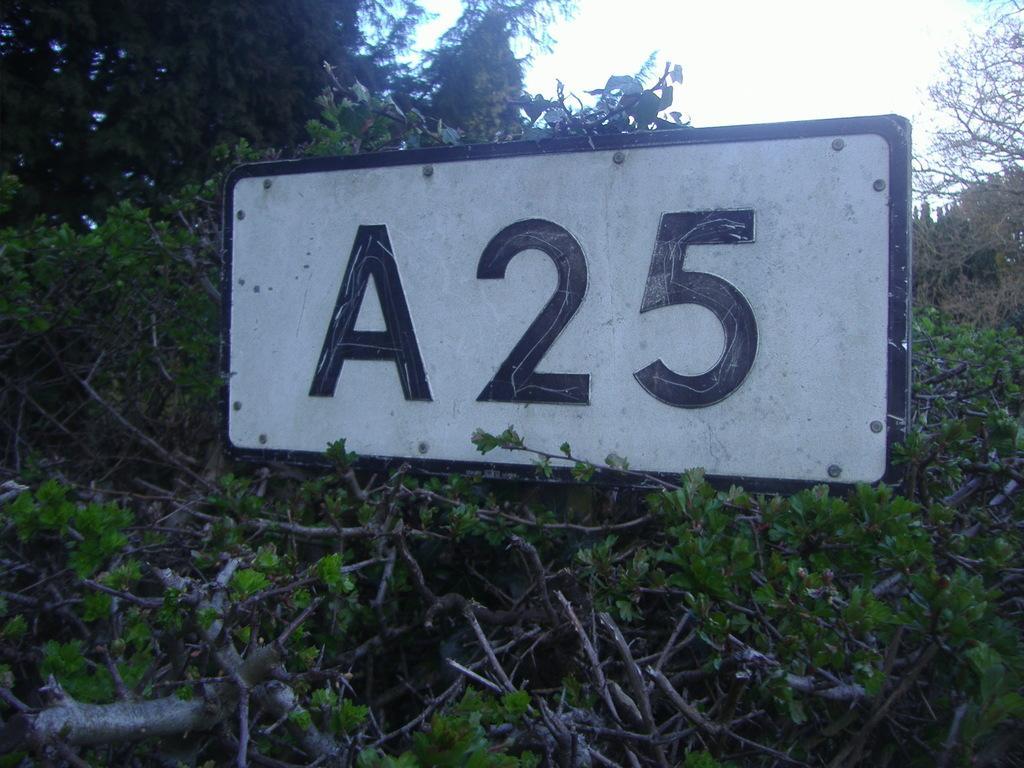Can you describe this image briefly? In this image I can see the board in-between many trees. In the background I can see the sky. 